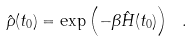<formula> <loc_0><loc_0><loc_500><loc_500>\hat { \rho } ( t _ { 0 } ) = \exp \left ( - \beta \hat { H } ( t _ { 0 } ) \right ) \ .</formula> 